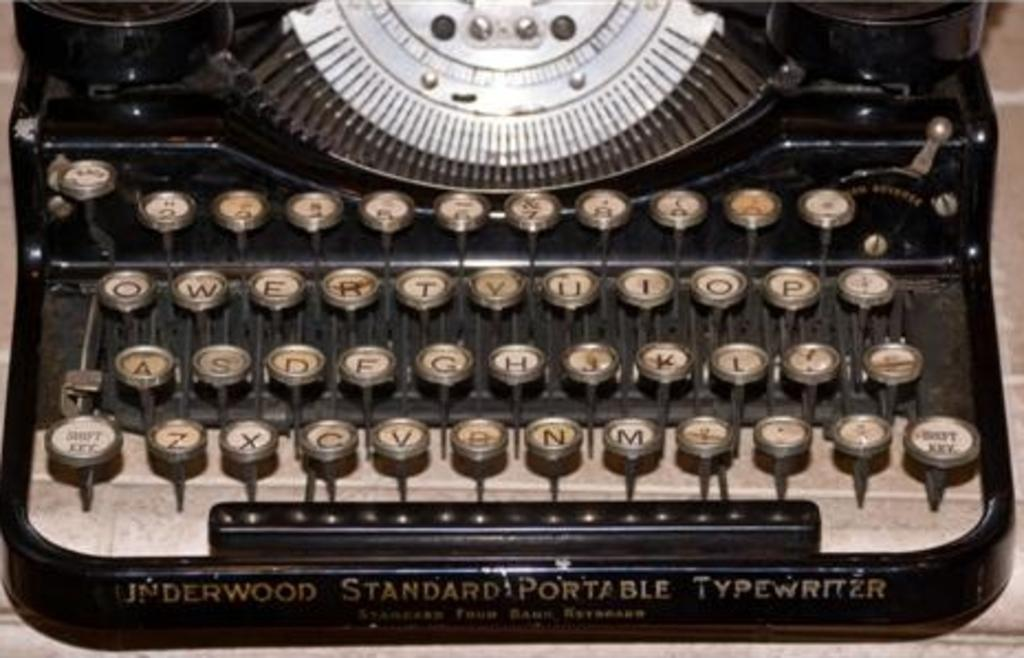<image>
Summarize the visual content of the image. A Underwoof Standard Portable Typewriter is sitting on a table. 